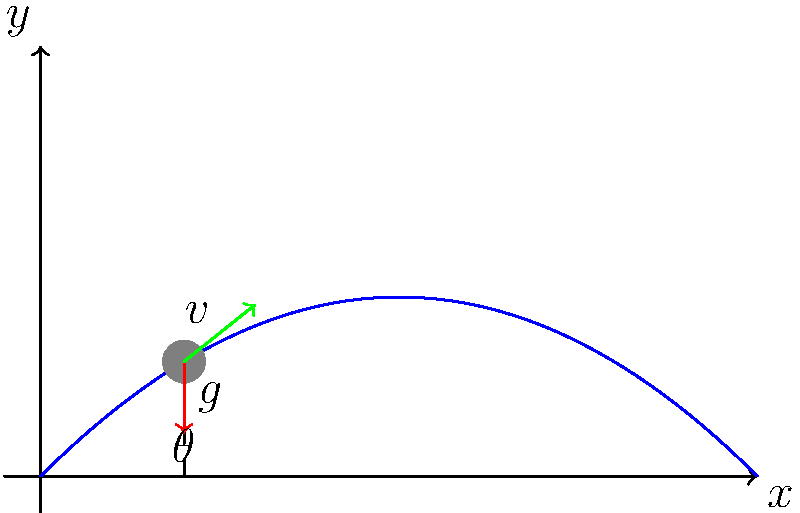As a marketing strategist for a horse breeder, you're creating a promotional video showcasing the perfect horse jump. The video will demonstrate the physics behind the jump to educate potential buyers. Given that the initial velocity of the horse is 10 m/s and the acceleration due to gravity is 9.8 m/s², what is the optimal angle θ for the horse to achieve the maximum horizontal distance in its jump? To find the optimal angle for the maximum horizontal distance, we can follow these steps:

1. The range (R) of a projectile (in this case, the horse's jump) is given by the equation:

   $$R = \frac{v^2 \sin(2\theta)}{g}$$

   Where:
   - $v$ is the initial velocity
   - $\theta$ is the launch angle
   - $g$ is the acceleration due to gravity

2. To maximize R, we need to maximize $\sin(2\theta)$. The maximum value of sine is 1, which occurs when its argument is 90°.

3. Therefore, the optimal angle is when:

   $$2\theta = 90°$$
   $$\theta = 45°$$

4. We can verify this mathematically by taking the derivative of R with respect to θ and setting it to zero:

   $$\frac{dR}{d\theta} = \frac{v^2}{g} \cdot 2\cos(2\theta) = 0$$

   This is true when $\cos(2\theta) = 0$, which occurs when $2\theta = 90°$ or $\theta = 45°$.

5. This result is independent of the initial velocity and the acceleration due to gravity, making it a universal optimal angle for achieving maximum range in projectile motion.

In the context of horse jumping, this means that to achieve the maximum horizontal distance, the horse should ideally leave the ground at a 45° angle relative to the horizontal.
Answer: 45° 